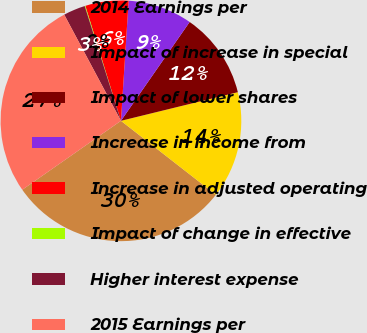<chart> <loc_0><loc_0><loc_500><loc_500><pie_chart><fcel>2014 Earnings per<fcel>Impact of increase in special<fcel>Impact of lower shares<fcel>Increase in income from<fcel>Increase in adjusted operating<fcel>Impact of change in effective<fcel>Higher interest expense<fcel>2015 Earnings per<nl><fcel>29.76%<fcel>14.36%<fcel>11.51%<fcel>8.65%<fcel>5.8%<fcel>0.09%<fcel>2.94%<fcel>26.9%<nl></chart> 